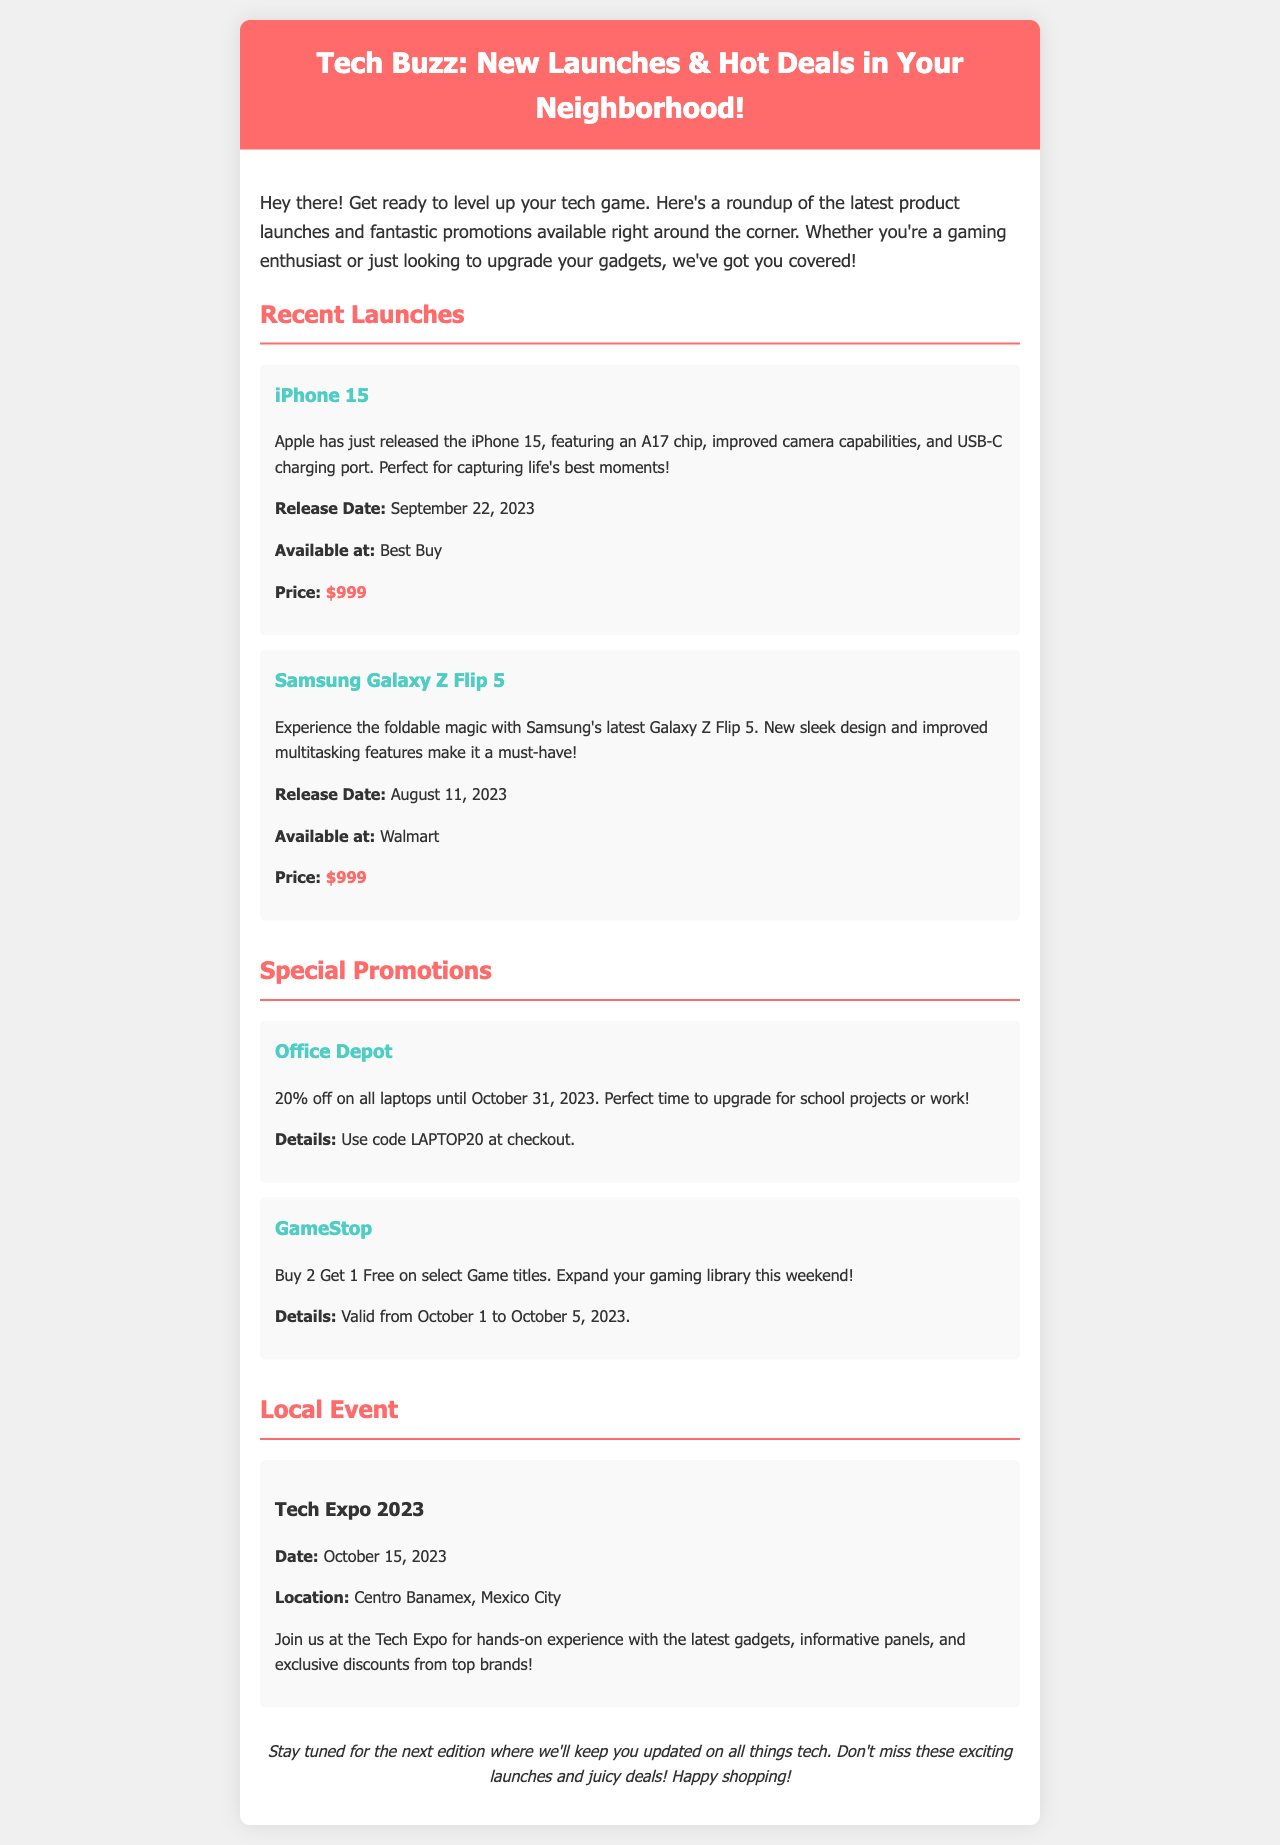¿Cuándo se lanzó el iPhone 15? El iPhone 15 fue lanzado el 22 de septiembre de 2023.
Answer: septiembre 22, 2023 ¿Cuál es el precio del Samsung Galaxy Z Flip 5? El precio del Samsung Galaxy Z Flip 5 es de $999.
Answer: $999 ¿Qué descuento ofrece Office Depot en laptops? Office Depot ofrece un 20% de descuento en todas las laptops.
Answer: 20% ¿Cuál es la ubicación del Tech Expo 2023? El Tech Expo 2023 se llevará a cabo en el Centro Banamex, Ciudad de México.
Answer: Centro Banamex, Ciudad de México ¿Cuándo es válida la promoción de GameStop? La promoción de GameStop es válida del 1 al 5 de octubre de 2023.
Answer: octubre 1 al 5, 2023 ¿Qué producto es mencionado junto a su fecha de lanzamiento el 11 de agosto de 2023? El producto mencionado con esa fecha es el Samsung Galaxy Z Flip 5.
Answer: Samsung Galaxy Z Flip 5 ¿Cuál es el código de descuento para la promoción de Office Depot? El código de descuento para Office Depot es LAPTOP20.
Answer: LAPTOP20 ¿Qué tipo de evento se menciona en el boletín? El evento mencionado es una exposición de tecnología.
Answer: exposición de tecnología 